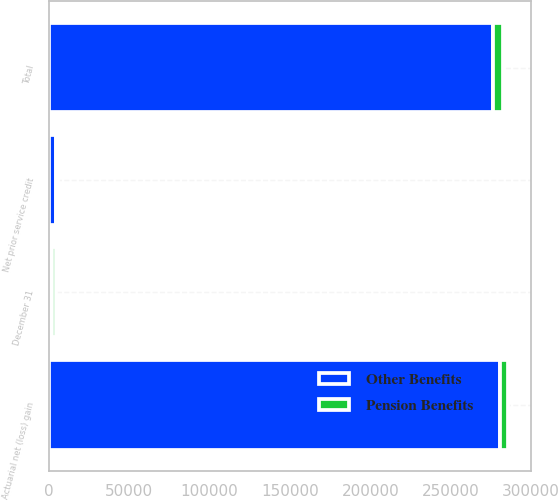Convert chart to OTSL. <chart><loc_0><loc_0><loc_500><loc_500><stacked_bar_chart><ecel><fcel>December 31<fcel>Actuarial net (loss) gain<fcel>Net prior service credit<fcel>Total<nl><fcel>Other Benefits<fcel>2010<fcel>280936<fcel>4265<fcel>276671<nl><fcel>Pension Benefits<fcel>2010<fcel>5118<fcel>973<fcel>6091<nl></chart> 